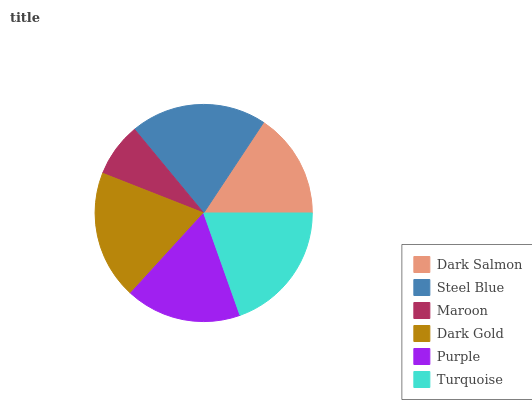Is Maroon the minimum?
Answer yes or no. Yes. Is Steel Blue the maximum?
Answer yes or no. Yes. Is Steel Blue the minimum?
Answer yes or no. No. Is Maroon the maximum?
Answer yes or no. No. Is Steel Blue greater than Maroon?
Answer yes or no. Yes. Is Maroon less than Steel Blue?
Answer yes or no. Yes. Is Maroon greater than Steel Blue?
Answer yes or no. No. Is Steel Blue less than Maroon?
Answer yes or no. No. Is Dark Gold the high median?
Answer yes or no. Yes. Is Purple the low median?
Answer yes or no. Yes. Is Maroon the high median?
Answer yes or no. No. Is Steel Blue the low median?
Answer yes or no. No. 